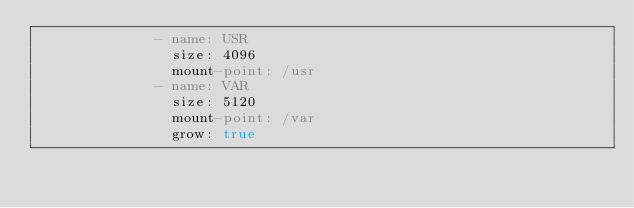Convert code to text. <code><loc_0><loc_0><loc_500><loc_500><_YAML_>              - name: USR
                size: 4096
                mount-point: /usr
              - name: VAR
                size: 5120
                mount-point: /var
                grow: true
</code> 